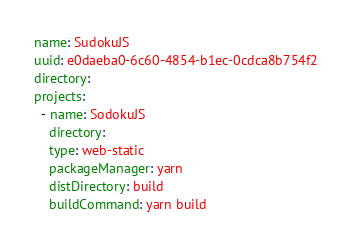<code> <loc_0><loc_0><loc_500><loc_500><_YAML_>name: SudokuJS
uuid: e0daeba0-6c60-4854-b1ec-0cdca8b754f2
directory:
projects:
  - name: SodokuJS
    directory:
    type: web-static
    packageManager: yarn
    distDirectory: build
    buildCommand: yarn build</code> 